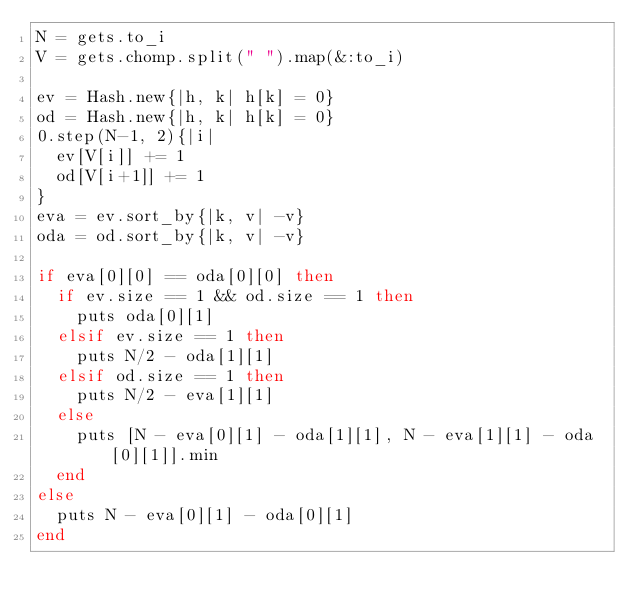Convert code to text. <code><loc_0><loc_0><loc_500><loc_500><_Ruby_>N = gets.to_i
V = gets.chomp.split(" ").map(&:to_i)

ev = Hash.new{|h, k| h[k] = 0}
od = Hash.new{|h, k| h[k] = 0}
0.step(N-1, 2){|i|
  ev[V[i]] += 1
  od[V[i+1]] += 1
}
eva = ev.sort_by{|k, v| -v}
oda = od.sort_by{|k, v| -v}

if eva[0][0] == oda[0][0] then
  if ev.size == 1 && od.size == 1 then
    puts oda[0][1]
  elsif ev.size == 1 then
    puts N/2 - oda[1][1]
  elsif od.size == 1 then
    puts N/2 - eva[1][1]
  else
    puts [N - eva[0][1] - oda[1][1], N - eva[1][1] - oda[0][1]].min
  end
else
  puts N - eva[0][1] - oda[0][1]
end
</code> 